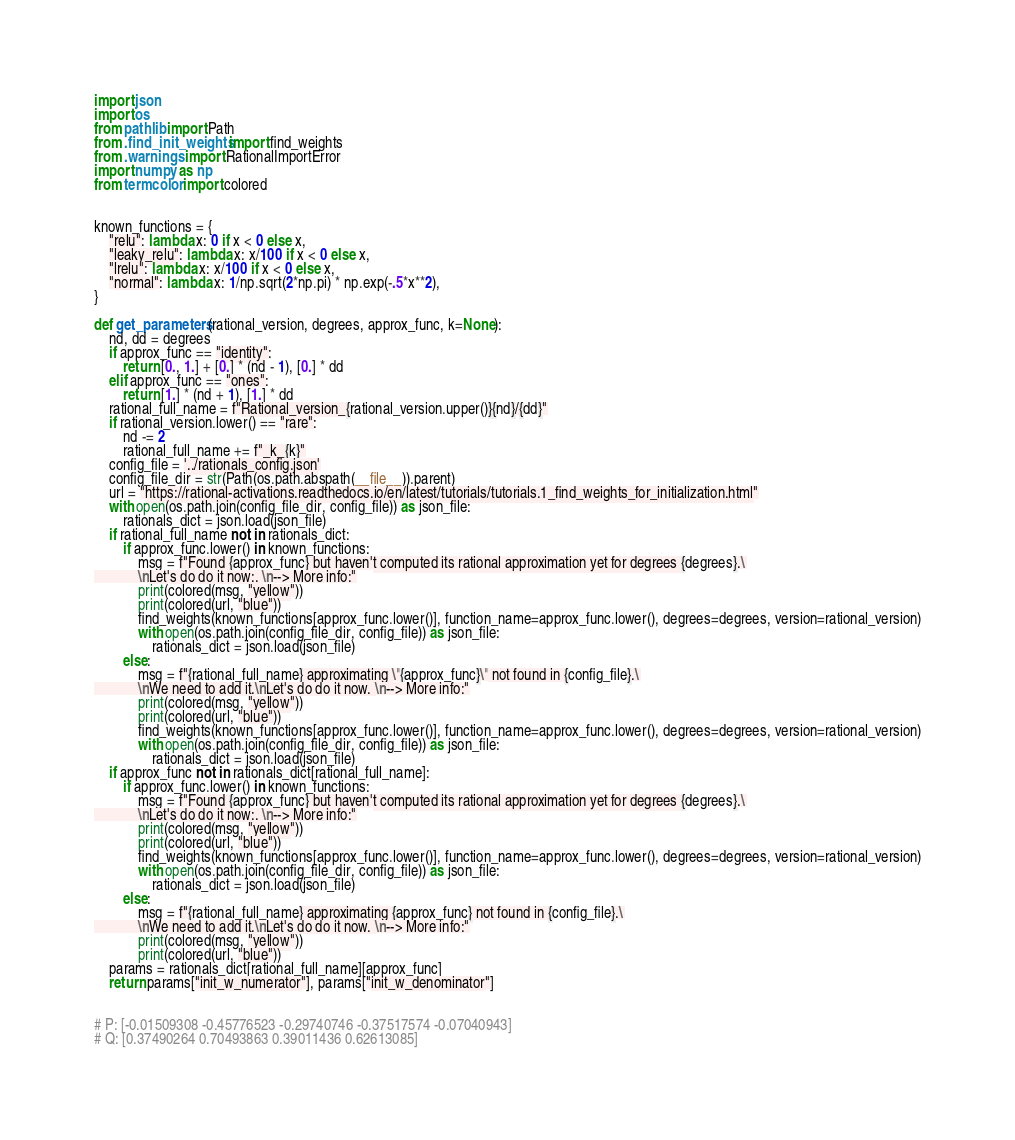<code> <loc_0><loc_0><loc_500><loc_500><_Python_>import json
import os
from pathlib import Path
from .find_init_weights import find_weights
from .warnings import RationalImportError
import numpy as np
from termcolor import colored


known_functions = {
    "relu": lambda x: 0 if x < 0 else x,
    "leaky_relu": lambda x: x/100 if x < 0 else x,
    "lrelu": lambda x: x/100 if x < 0 else x,
    "normal": lambda x: 1/np.sqrt(2*np.pi) * np.exp(-.5*x**2),
}

def get_parameters(rational_version, degrees, approx_func, k=None):
    nd, dd = degrees
    if approx_func == "identity":
        return [0., 1.] + [0.] * (nd - 1), [0.] * dd
    elif approx_func == "ones":
        return [1.] * (nd + 1), [1.] * dd
    rational_full_name = f"Rational_version_{rational_version.upper()}{nd}/{dd}"
    if rational_version.lower() == "rare":
        nd -= 2
        rational_full_name += f"_k_{k}"
    config_file = '../rationals_config.json'
    config_file_dir = str(Path(os.path.abspath(__file__)).parent)
    url = "https://rational-activations.readthedocs.io/en/latest/tutorials/tutorials.1_find_weights_for_initialization.html"
    with open(os.path.join(config_file_dir, config_file)) as json_file:
        rationals_dict = json.load(json_file)
    if rational_full_name not in rationals_dict:
        if approx_func.lower() in known_functions:
            msg = f"Found {approx_func} but haven't computed its rational approximation yet for degrees {degrees}.\
            \nLet's do do it now:. \n--> More info:"
            print(colored(msg, "yellow"))
            print(colored(url, "blue"))
            find_weights(known_functions[approx_func.lower()], function_name=approx_func.lower(), degrees=degrees, version=rational_version)
            with open(os.path.join(config_file_dir, config_file)) as json_file:
                rationals_dict = json.load(json_file)
        else:
            msg = f"{rational_full_name} approximating \"{approx_func}\" not found in {config_file}.\
            \nWe need to add it.\nLet's do do it now. \n--> More info:"
            print(colored(msg, "yellow"))
            print(colored(url, "blue"))
            find_weights(known_functions[approx_func.lower()], function_name=approx_func.lower(), degrees=degrees, version=rational_version)
            with open(os.path.join(config_file_dir, config_file)) as json_file:
                rationals_dict = json.load(json_file)
    if approx_func not in rationals_dict[rational_full_name]:
        if approx_func.lower() in known_functions:
            msg = f"Found {approx_func} but haven't computed its rational approximation yet for degrees {degrees}.\
            \nLet's do do it now:. \n--> More info:"
            print(colored(msg, "yellow"))
            print(colored(url, "blue"))
            find_weights(known_functions[approx_func.lower()], function_name=approx_func.lower(), degrees=degrees, version=rational_version)
            with open(os.path.join(config_file_dir, config_file)) as json_file:
                rationals_dict = json.load(json_file)
        else:
            msg = f"{rational_full_name} approximating {approx_func} not found in {config_file}.\
            \nWe need to add it.\nLet's do do it now. \n--> More info:"
            print(colored(msg, "yellow"))
            print(colored(url, "blue"))
    params = rationals_dict[rational_full_name][approx_func]
    return params["init_w_numerator"], params["init_w_denominator"]


# P: [-0.01509308 -0.45776523 -0.29740746 -0.37517574 -0.07040943]
# Q: [0.37490264 0.70493863 0.39011436 0.62613085]
</code> 